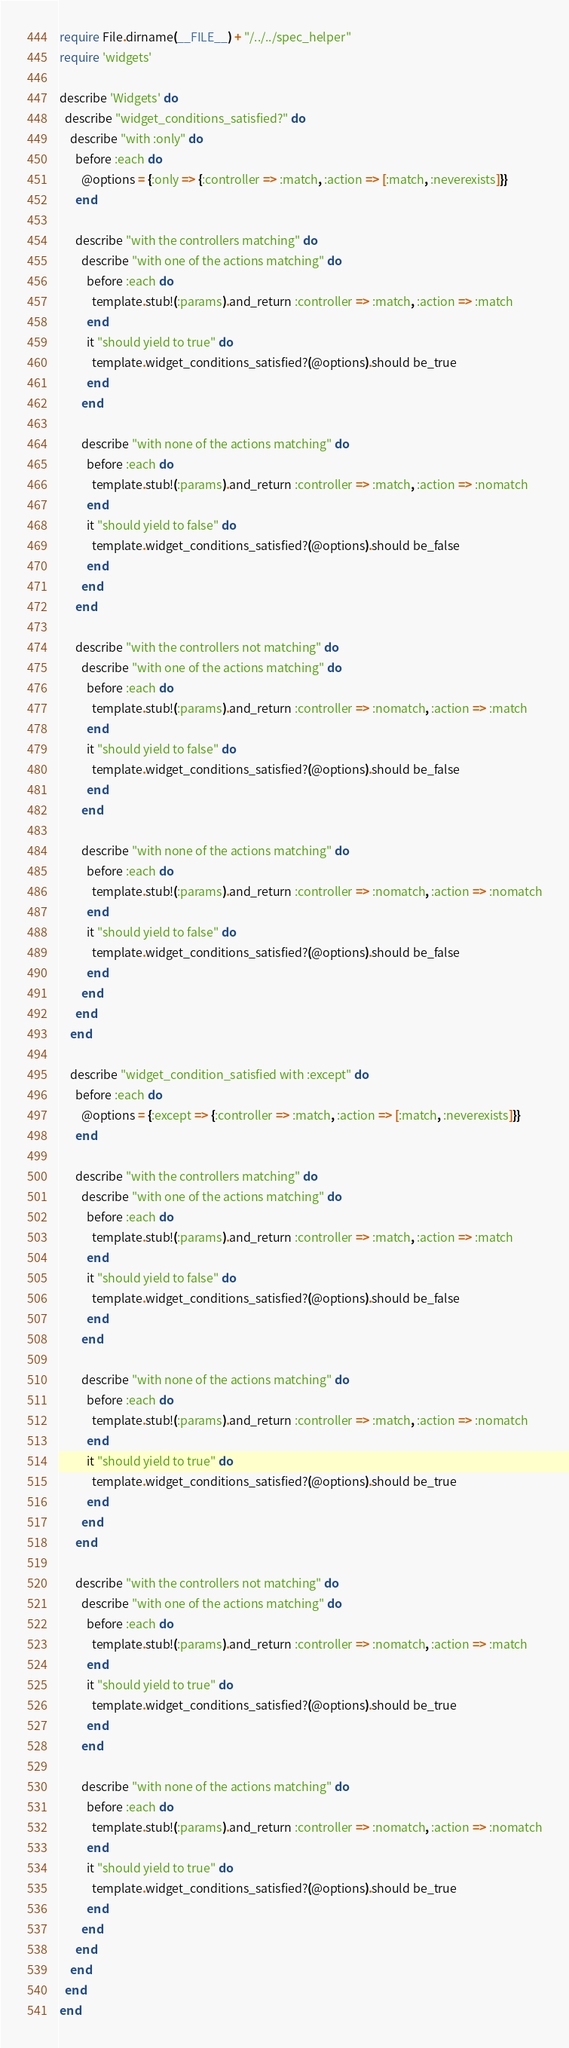<code> <loc_0><loc_0><loc_500><loc_500><_Ruby_>require File.dirname(__FILE__) + "/../../spec_helper"
require 'widgets'

describe 'Widgets' do
  describe "widget_conditions_satisfied?" do
    describe "with :only" do
      before :each do
        @options = {:only => {:controller => :match, :action => [:match, :neverexists]}}
      end
  
      describe "with the controllers matching" do
        describe "with one of the actions matching" do
          before :each do
            template.stub!(:params).and_return :controller => :match, :action => :match
          end      
          it "should yield to true" do
            template.widget_conditions_satisfied?(@options).should be_true
          end
        end
        
        describe "with none of the actions matching" do
          before :each do
            template.stub!(:params).and_return :controller => :match, :action => :nomatch
          end      
          it "should yield to false" do
            template.widget_conditions_satisfied?(@options).should be_false
          end
        end
      end
      
      describe "with the controllers not matching" do
        describe "with one of the actions matching" do
          before :each do
            template.stub!(:params).and_return :controller => :nomatch, :action => :match
          end      
          it "should yield to false" do
            template.widget_conditions_satisfied?(@options).should be_false
          end
        end
        
        describe "with none of the actions matching" do
          before :each do
            template.stub!(:params).and_return :controller => :nomatch, :action => :nomatch
          end      
          it "should yield to false" do
            template.widget_conditions_satisfied?(@options).should be_false
          end
        end
      end
    end
  
    describe "widget_condition_satisfied with :except" do
      before :each do
        @options = {:except => {:controller => :match, :action => [:match, :neverexists]}}
      end
      
      describe "with the controllers matching" do
        describe "with one of the actions matching" do
          before :each do
            template.stub!(:params).and_return :controller => :match, :action => :match
          end      
          it "should yield to false" do
            template.widget_conditions_satisfied?(@options).should be_false
          end
        end
        
        describe "with none of the actions matching" do
          before :each do
            template.stub!(:params).and_return :controller => :match, :action => :nomatch
          end      
          it "should yield to true" do
            template.widget_conditions_satisfied?(@options).should be_true
          end
        end
      end
      
      describe "with the controllers not matching" do
        describe "with one of the actions matching" do
          before :each do
            template.stub!(:params).and_return :controller => :nomatch, :action => :match
          end      
          it "should yield to true" do
            template.widget_conditions_satisfied?(@options).should be_true
          end
        end
        
        describe "with none of the actions matching" do
          before :each do
            template.stub!(:params).and_return :controller => :nomatch, :action => :nomatch
          end      
          it "should yield to true" do
            template.widget_conditions_satisfied?(@options).should be_true
          end
        end
      end
    end
  end
end</code> 